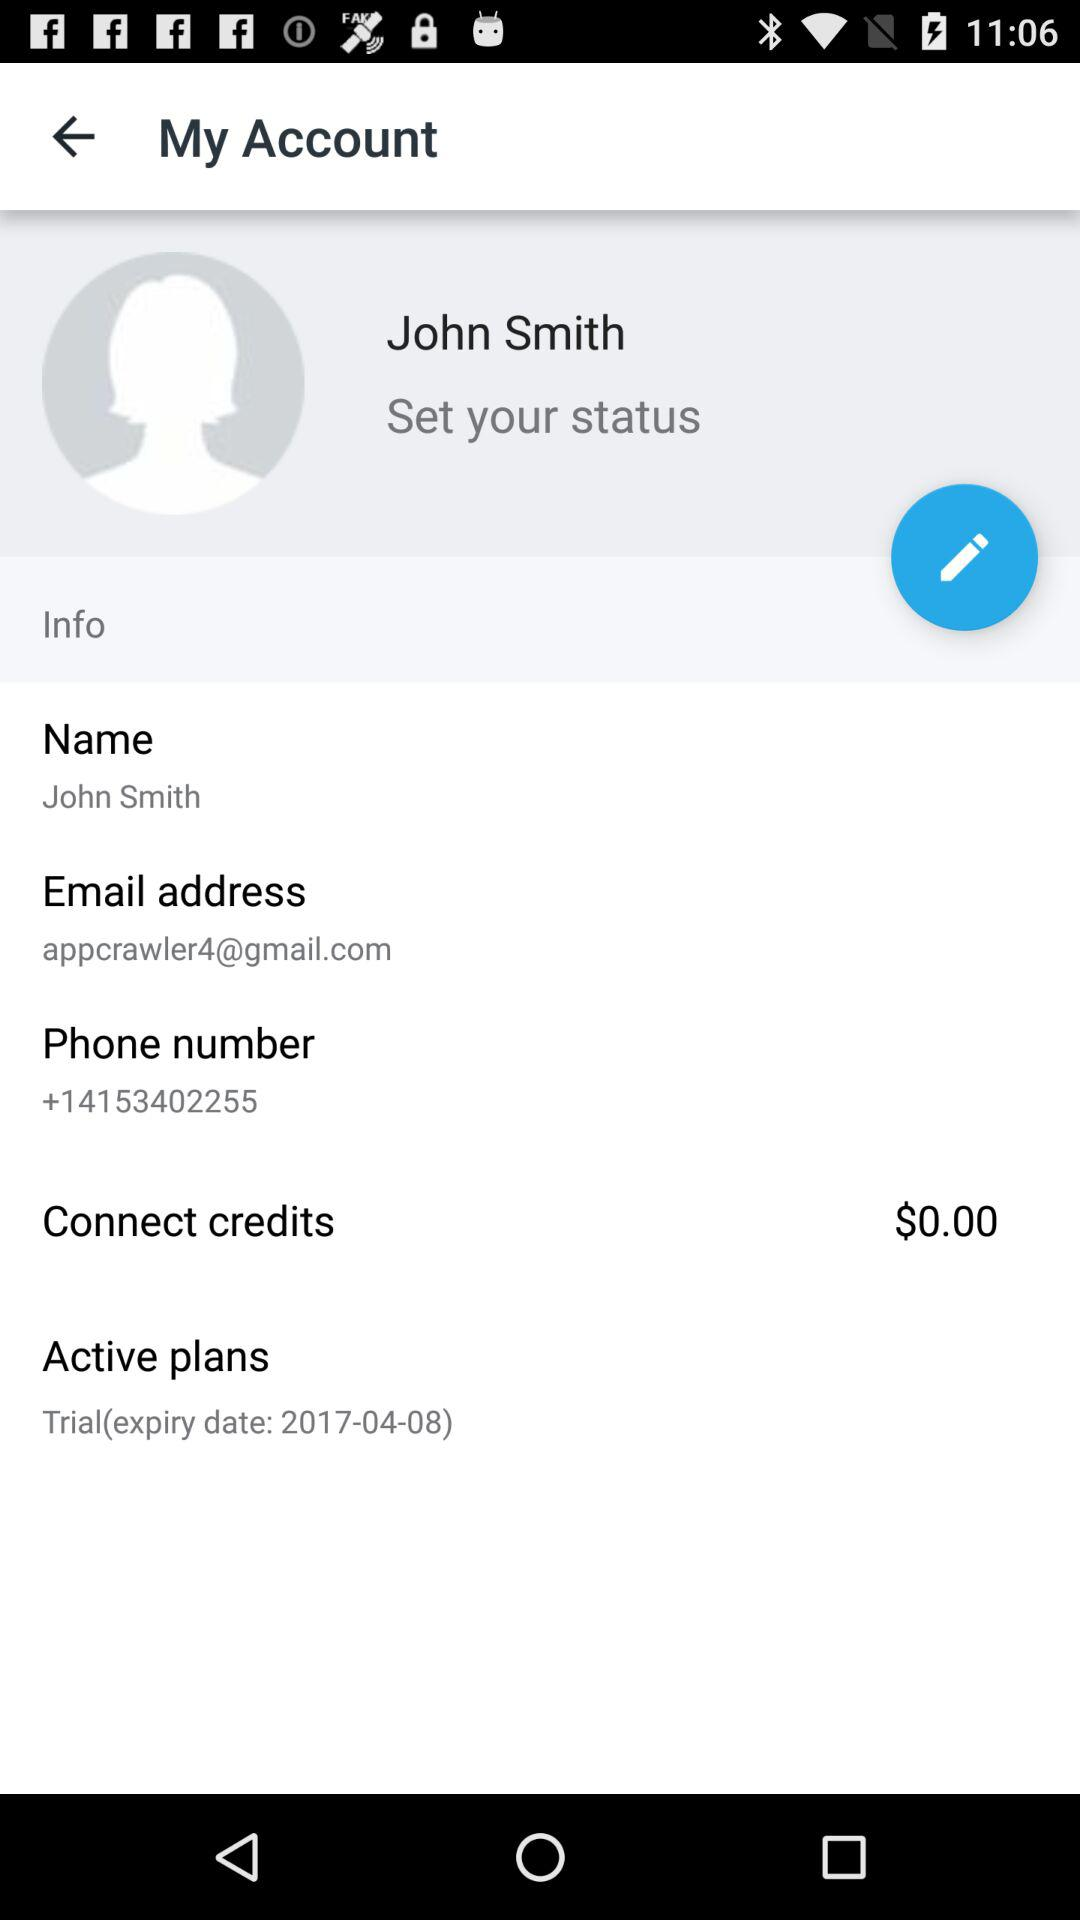What is the profile name? The profile name is John Smith. 